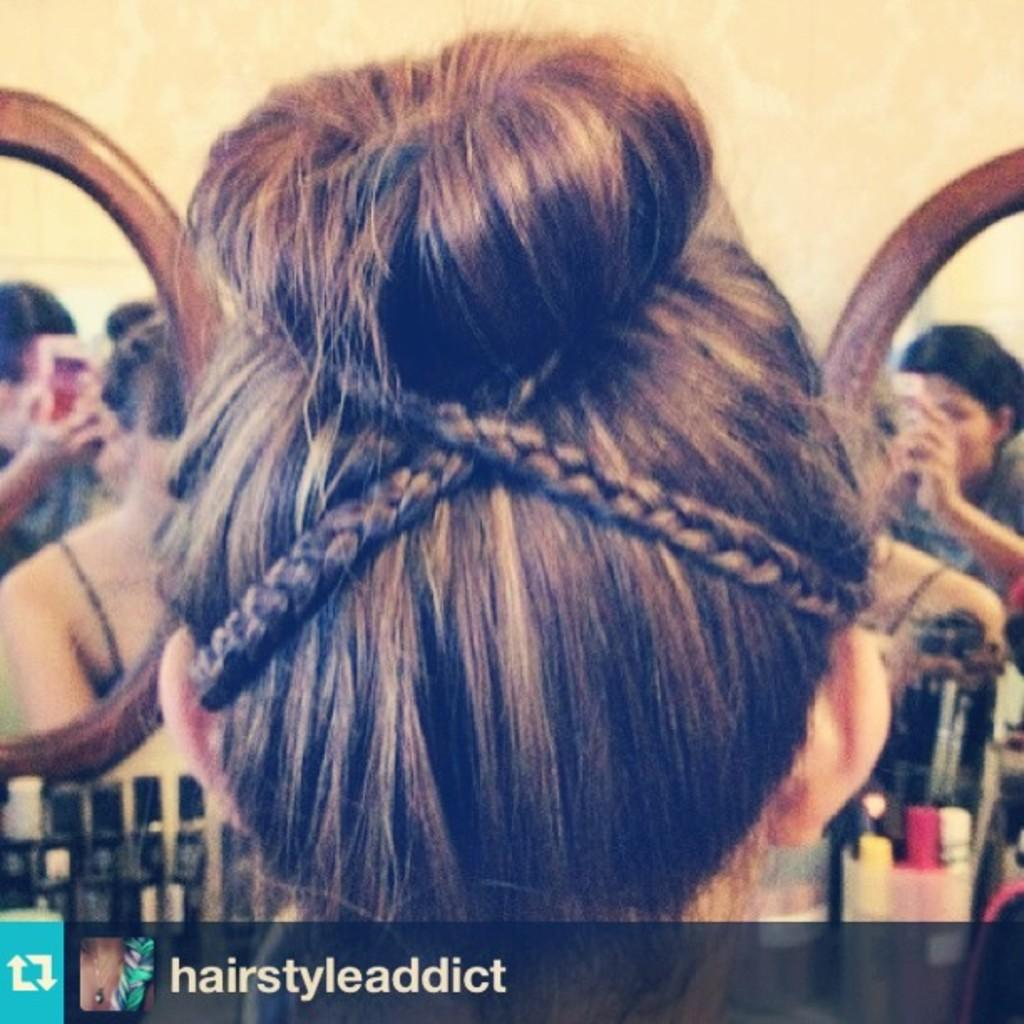What is the main subject of the image? There is a person in the image. Can you describe the person's appearance? The person's hairstyle is visible in the image. Are there any other people in the image? Yes, there are other persons in the background of the image. What type of humor can be seen in the duck's behavior in the image? There is no duck present in the image, so it is not possible to determine the duck's behavior or sense of humor. 